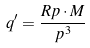<formula> <loc_0><loc_0><loc_500><loc_500>q ^ { \prime } = \frac { R p \cdot M } { p ^ { 3 } }</formula> 